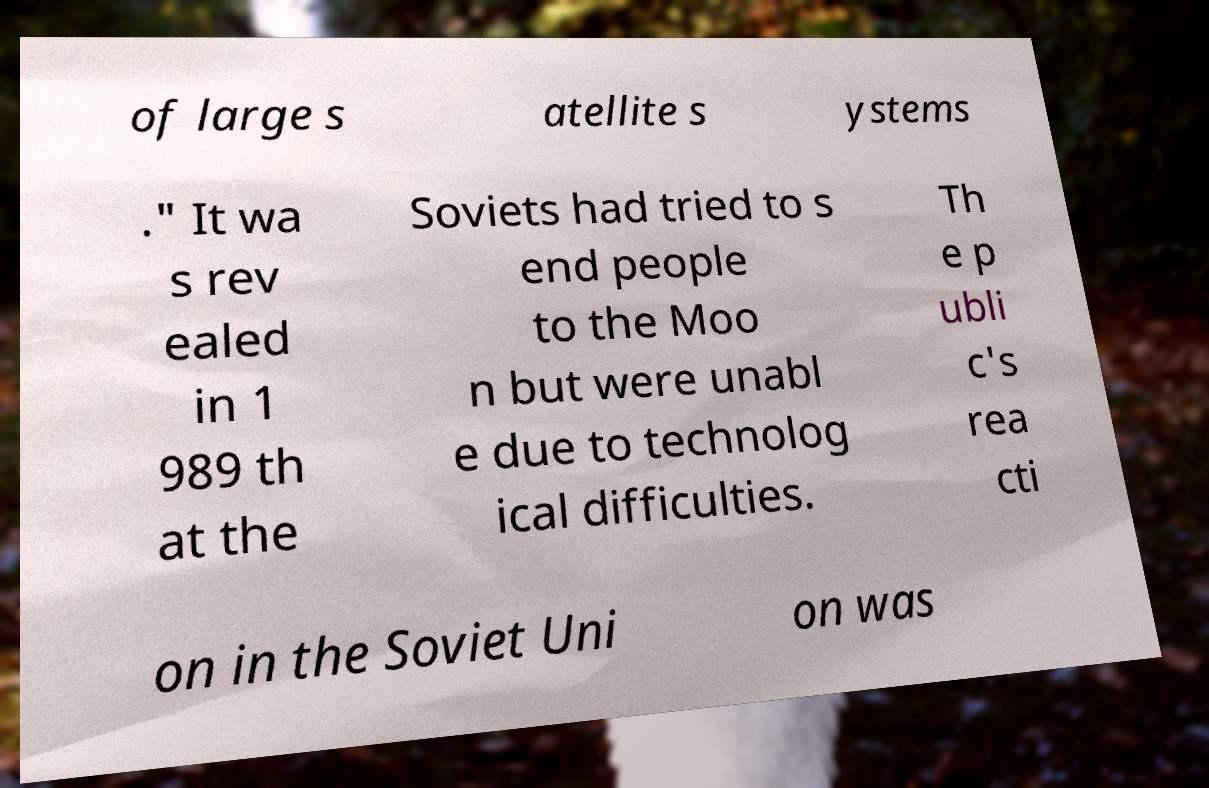Can you accurately transcribe the text from the provided image for me? of large s atellite s ystems ." It wa s rev ealed in 1 989 th at the Soviets had tried to s end people to the Moo n but were unabl e due to technolog ical difficulties. Th e p ubli c's rea cti on in the Soviet Uni on was 